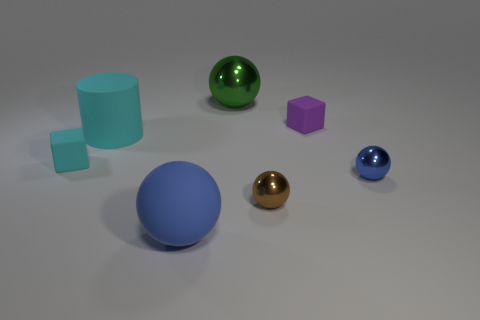There is a matte thing that is the same color as the cylinder; what size is it?
Give a very brief answer. Small. What size is the blue object that is the same material as the brown ball?
Provide a succinct answer. Small. Does the matte cube right of the big green shiny object have the same size as the blue thing behind the brown metal ball?
Your response must be concise. Yes. How many things are either small purple matte cubes or cubes?
Your answer should be compact. 2. What is the shape of the small blue object?
Make the answer very short. Sphere. There is a brown object that is the same shape as the big green shiny object; what size is it?
Keep it short and to the point. Small. Is there anything else that is the same material as the large blue thing?
Keep it short and to the point. Yes. There is a matte block that is on the left side of the small sphere that is in front of the blue metallic ball; how big is it?
Offer a very short reply. Small. Is the number of rubber things right of the small blue sphere the same as the number of big matte things?
Your answer should be very brief. No. What number of other objects are there of the same color as the large rubber sphere?
Your response must be concise. 1. 